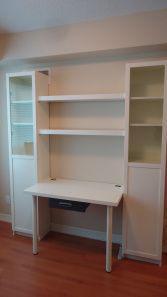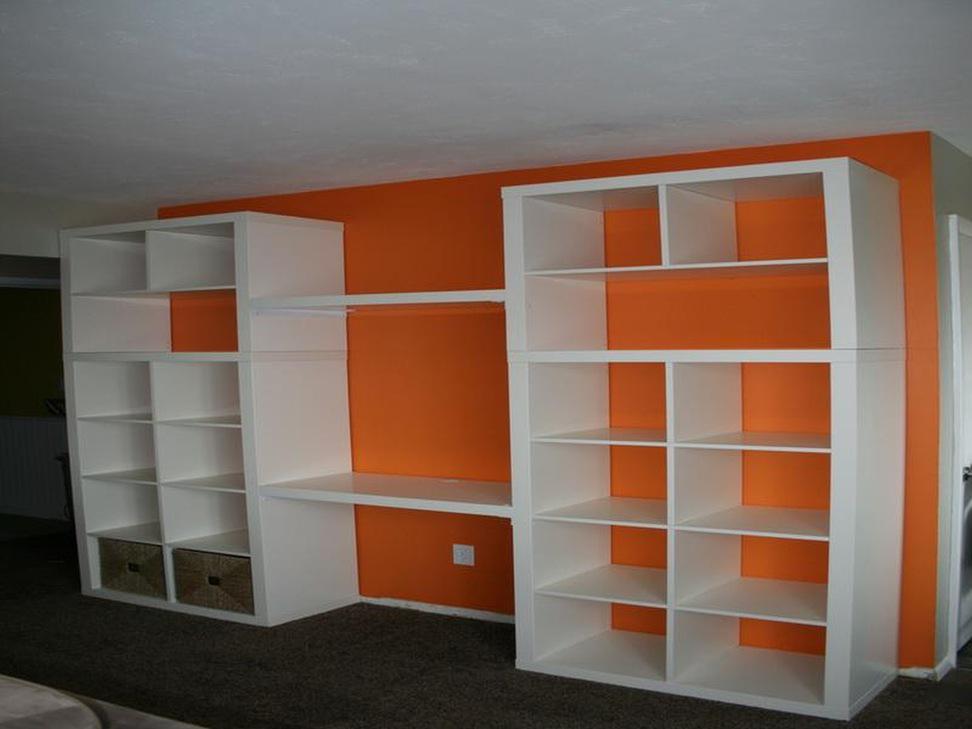The first image is the image on the left, the second image is the image on the right. Examine the images to the left and right. Is the description "An image shows a white bookcase unit in front of a bright orange divider wall." accurate? Answer yes or no. Yes. The first image is the image on the left, the second image is the image on the right. For the images shown, is this caption "In one of the images, there are built in bookcases attached to a bright orange wall." true? Answer yes or no. Yes. 